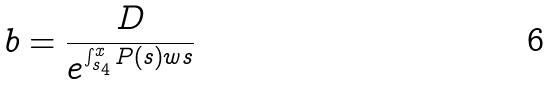Convert formula to latex. <formula><loc_0><loc_0><loc_500><loc_500>b = \frac { D } { e ^ { \int _ { s _ { 4 } } ^ { x } P ( s ) w s } }</formula> 